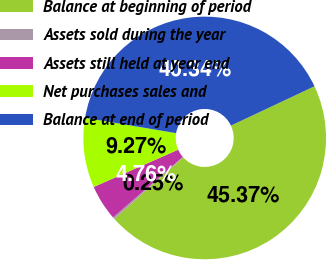<chart> <loc_0><loc_0><loc_500><loc_500><pie_chart><fcel>Balance at beginning of period<fcel>Assets sold during the year<fcel>Assets still held at year end<fcel>Net purchases sales and<fcel>Balance at end of period<nl><fcel>45.37%<fcel>0.25%<fcel>4.76%<fcel>9.27%<fcel>40.34%<nl></chart> 